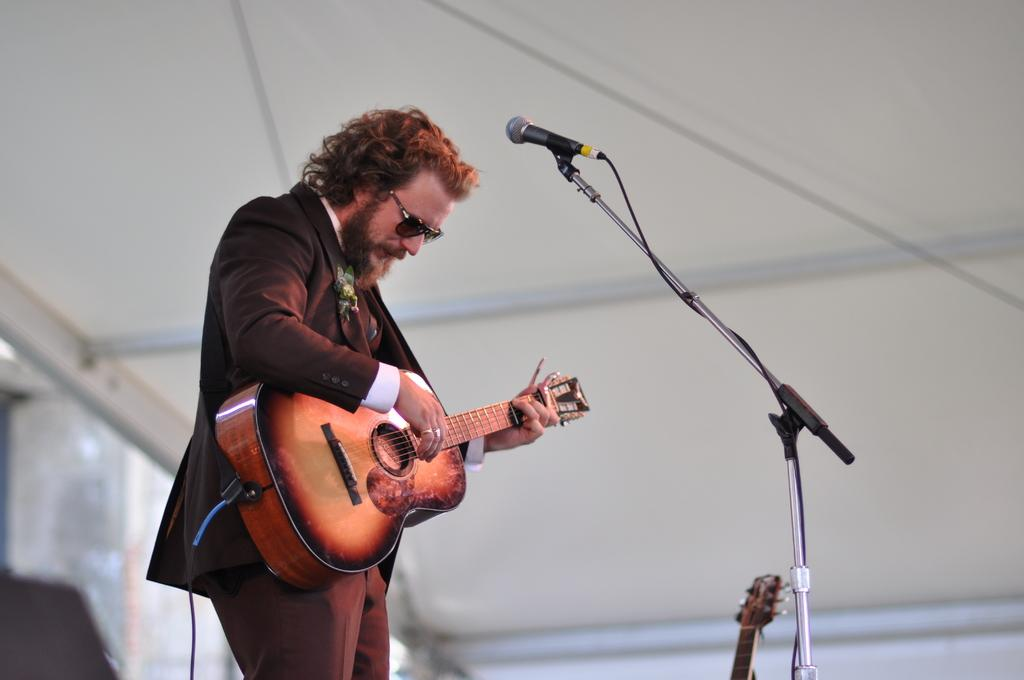Who is the main subject in the image? There is a man in the image. What is the man wearing on his face? The man is wearing brown-colored goggles. What object is the man holding in the image? The man is holding a guitar. What device is present for amplifying sound in the image? There is a microphone in the image. What color is the man's attire in the image? The man is wearing a brown-colored attire. What type of sand can be seen on the stage in the image? There is no sand or stage present in the image; it features a man holding a guitar and wearing goggles. How many volleyballs are visible in the image? There are no volleyballs present in the image. 